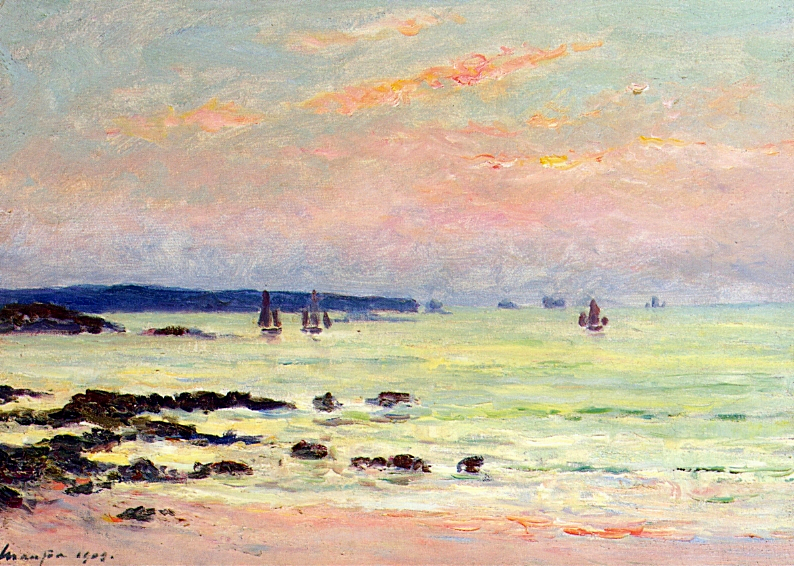What time of day does this painting represent, and what mood does it evoke? The image suggests it could be early morning or late afternoon, a time when the light casts soft hues of pink and orange across the sky, mirrored on the water's surface. This serene ambiance, combined with the gentle movement of the sailboats, evokes a mood of tranquility and quiet contemplation. 